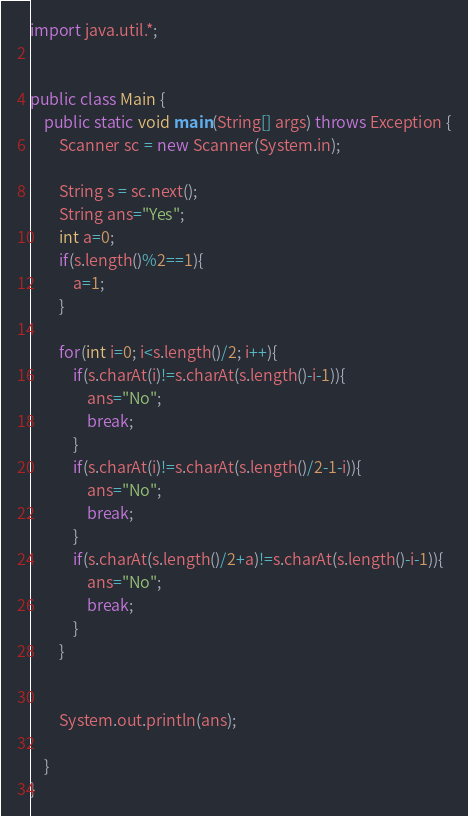Convert code to text. <code><loc_0><loc_0><loc_500><loc_500><_Java_>import java.util.*;


public class Main {
    public static void main(String[] args) throws Exception {
        Scanner sc = new Scanner(System.in);
        
        String s = sc.next();
        String ans="Yes";
        int a=0;
        if(s.length()%2==1){
            a=1;
        }
        
        for(int i=0; i<s.length()/2; i++){
            if(s.charAt(i)!=s.charAt(s.length()-i-1)){
                ans="No";
                break;
            }
            if(s.charAt(i)!=s.charAt(s.length()/2-1-i)){
                ans="No";
                break;
            }
            if(s.charAt(s.length()/2+a)!=s.charAt(s.length()-i-1)){
                ans="No";
                break;
            }
        }
        
        
        System.out.println(ans);
        
	}
}
</code> 